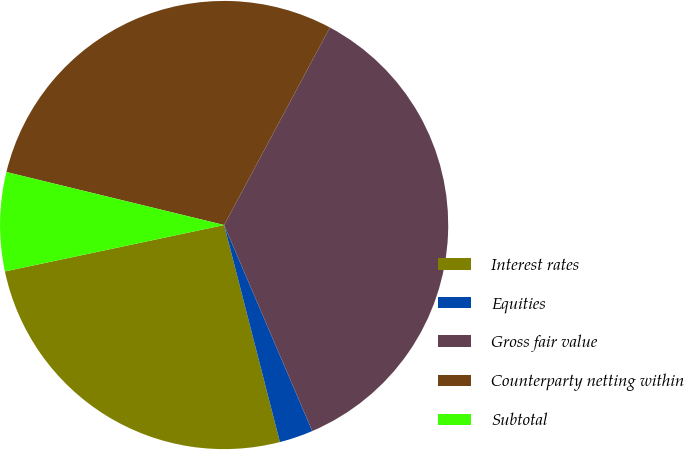<chart> <loc_0><loc_0><loc_500><loc_500><pie_chart><fcel>Interest rates<fcel>Equities<fcel>Gross fair value<fcel>Counterparty netting within<fcel>Subtotal<nl><fcel>25.68%<fcel>2.43%<fcel>35.74%<fcel>29.02%<fcel>7.12%<nl></chart> 